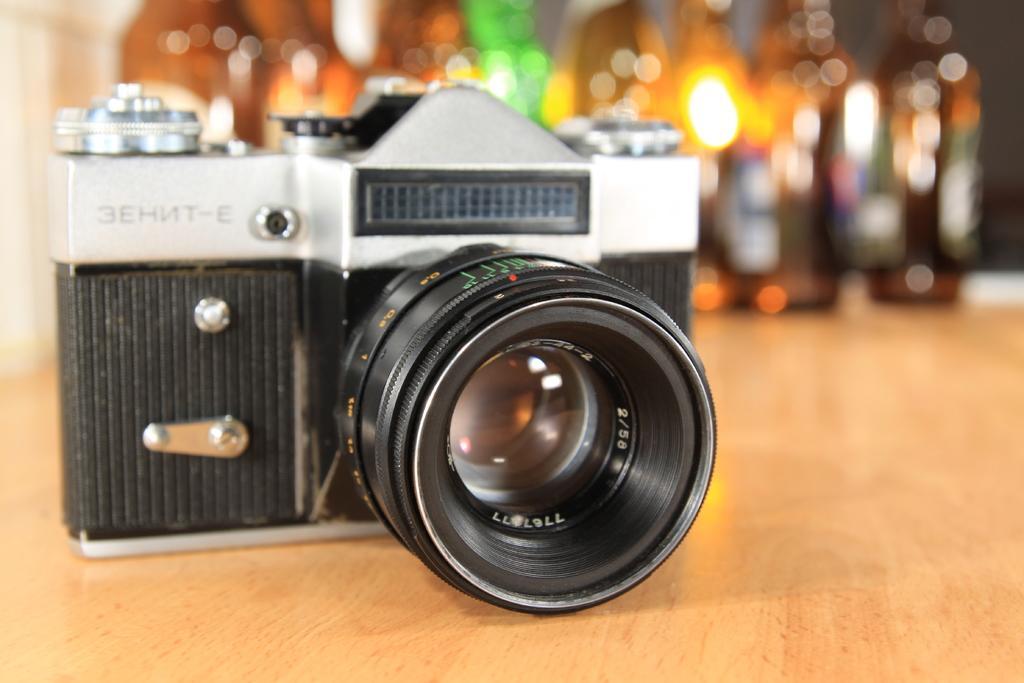Please provide a concise description of this image. In this image in the front there is a camera which is black and silver in colour and the background is blurry. 